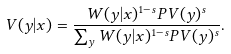<formula> <loc_0><loc_0><loc_500><loc_500>V ( y | x ) = \frac { W ( y | x ) ^ { 1 - s } P V ( y ) ^ { s } } { \sum _ { y } W ( y | x ) ^ { 1 - s } P V ( y ) ^ { s } } .</formula> 